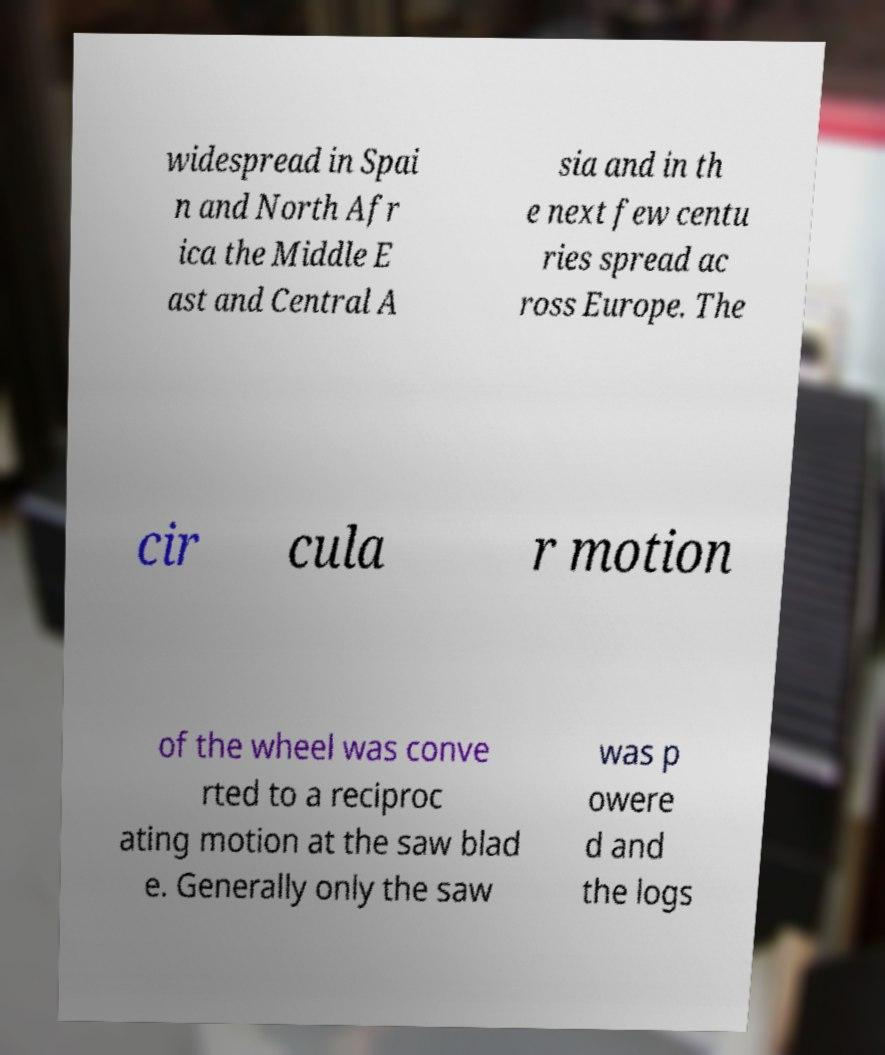Could you extract and type out the text from this image? widespread in Spai n and North Afr ica the Middle E ast and Central A sia and in th e next few centu ries spread ac ross Europe. The cir cula r motion of the wheel was conve rted to a reciproc ating motion at the saw blad e. Generally only the saw was p owere d and the logs 